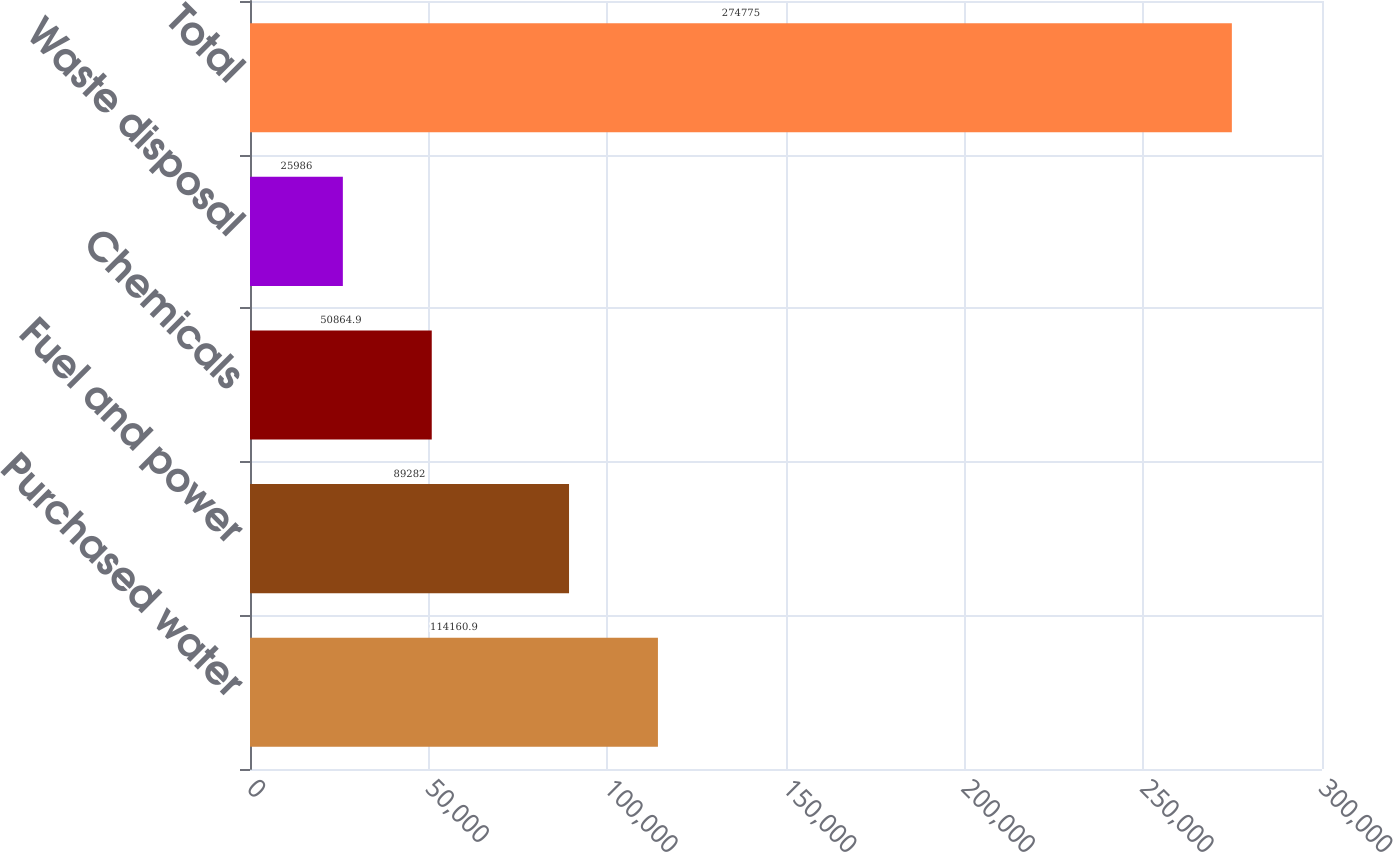Convert chart. <chart><loc_0><loc_0><loc_500><loc_500><bar_chart><fcel>Purchased water<fcel>Fuel and power<fcel>Chemicals<fcel>Waste disposal<fcel>Total<nl><fcel>114161<fcel>89282<fcel>50864.9<fcel>25986<fcel>274775<nl></chart> 